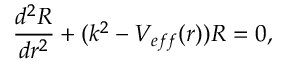Convert formula to latex. <formula><loc_0><loc_0><loc_500><loc_500>\frac { d ^ { 2 } R } { d r ^ { 2 } } + ( k ^ { 2 } - V _ { e f f } ( r ) ) R = 0 ,</formula> 